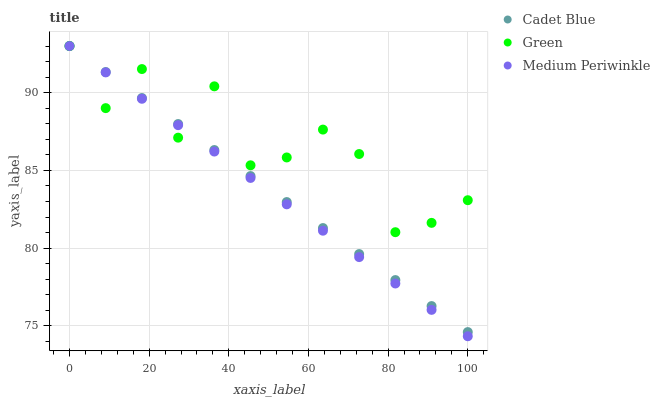Does Medium Periwinkle have the minimum area under the curve?
Answer yes or no. Yes. Does Green have the maximum area under the curve?
Answer yes or no. Yes. Does Cadet Blue have the minimum area under the curve?
Answer yes or no. No. Does Cadet Blue have the maximum area under the curve?
Answer yes or no. No. Is Medium Periwinkle the smoothest?
Answer yes or no. Yes. Is Green the roughest?
Answer yes or no. Yes. Is Cadet Blue the smoothest?
Answer yes or no. No. Is Cadet Blue the roughest?
Answer yes or no. No. Does Medium Periwinkle have the lowest value?
Answer yes or no. Yes. Does Cadet Blue have the lowest value?
Answer yes or no. No. Does Green have the highest value?
Answer yes or no. Yes. Does Cadet Blue intersect Green?
Answer yes or no. Yes. Is Cadet Blue less than Green?
Answer yes or no. No. Is Cadet Blue greater than Green?
Answer yes or no. No. 